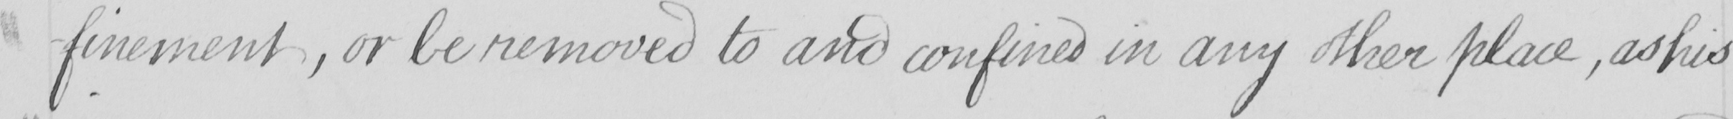Transcribe the text shown in this historical manuscript line. -finement , or be removed to and confined in any other place , as his 